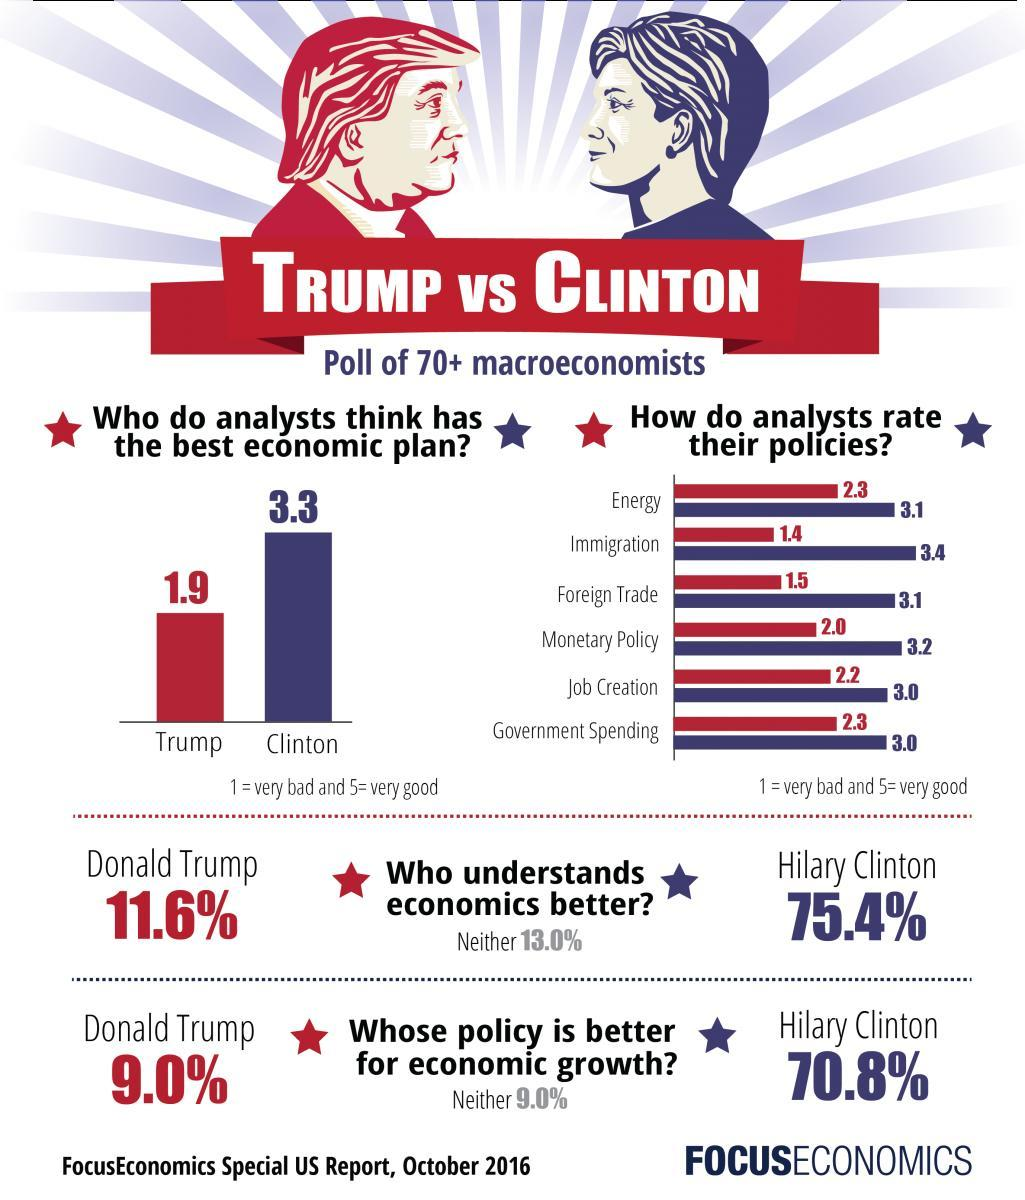Who has a better rating on the policy for  job creation, Trump or Hilary?
Answer the question with a short phrase. Hilary What percentage of people feel Trump's policy is better for economic growth, 75.4%, 9.0%, or, 70.8%? 9.0% Who among the Trump or Hilary, has a better rating for the best economic plan? Hilary What is the percentage of people feel Hilary Clinton understands economics better, 11.6%, 13.0%, or 75.4%? 75.4% 